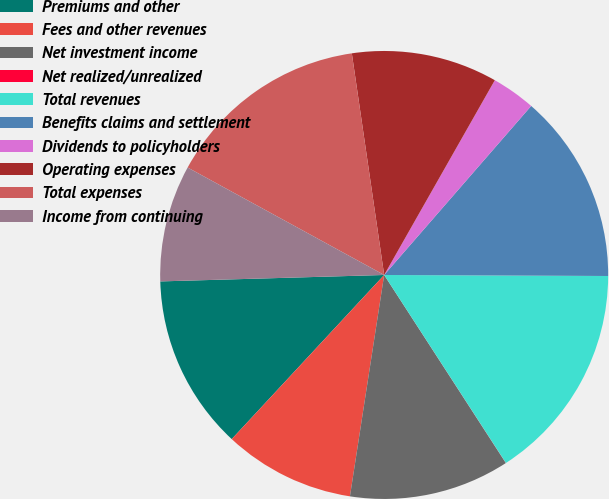<chart> <loc_0><loc_0><loc_500><loc_500><pie_chart><fcel>Premiums and other<fcel>Fees and other revenues<fcel>Net investment income<fcel>Net realized/unrealized<fcel>Total revenues<fcel>Benefits claims and settlement<fcel>Dividends to policyholders<fcel>Operating expenses<fcel>Total expenses<fcel>Income from continuing<nl><fcel>12.63%<fcel>9.47%<fcel>11.58%<fcel>0.01%<fcel>15.78%<fcel>13.68%<fcel>3.17%<fcel>10.53%<fcel>14.73%<fcel>8.42%<nl></chart> 